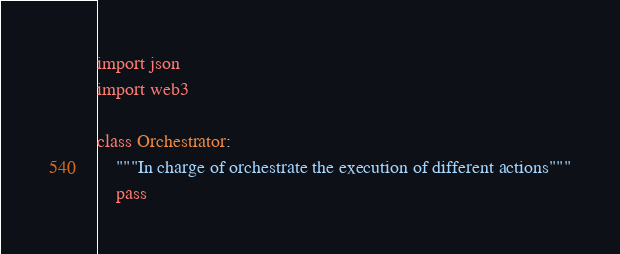<code> <loc_0><loc_0><loc_500><loc_500><_Python_>import json
import web3

class Orchestrator:
    """In charge of orchestrate the execution of different actions"""
    pass
</code> 